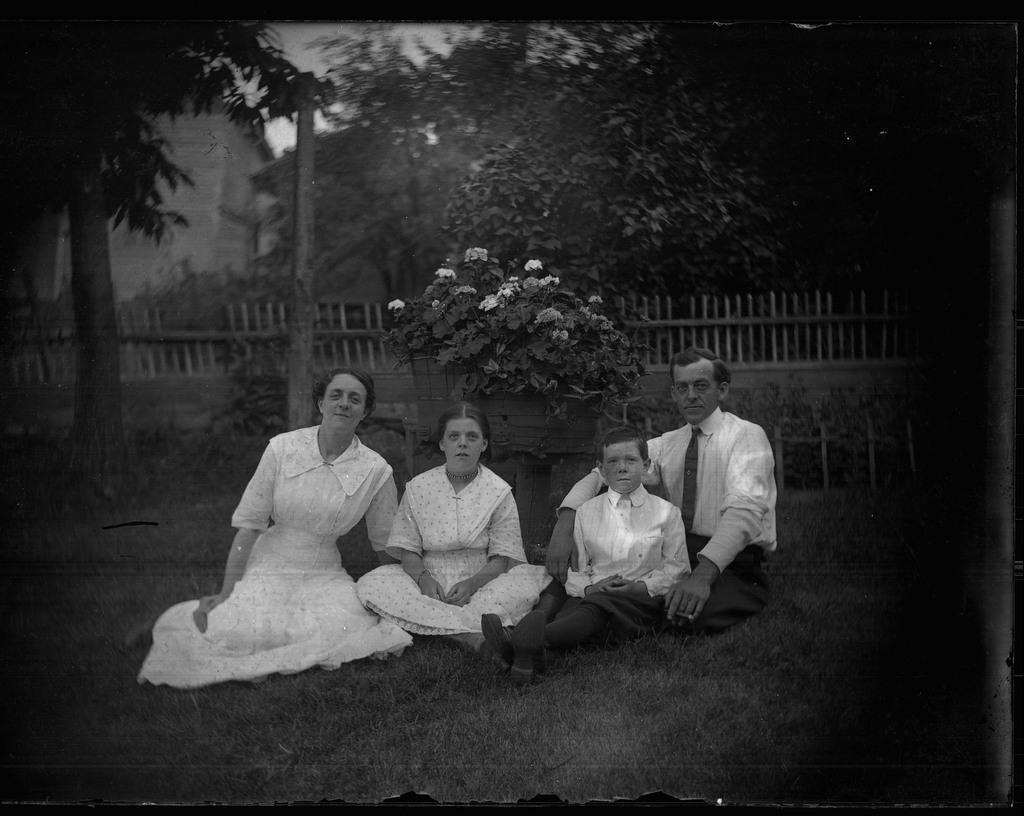Describe this image in one or two sentences. This is a black and white image. 4 people are sitting. Behind them there is a fencing and trees. 